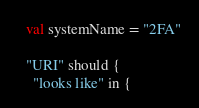<code> <loc_0><loc_0><loc_500><loc_500><_Scala_>  val systemName = "2FA"

  "URI" should {
    "looks like" in {</code> 